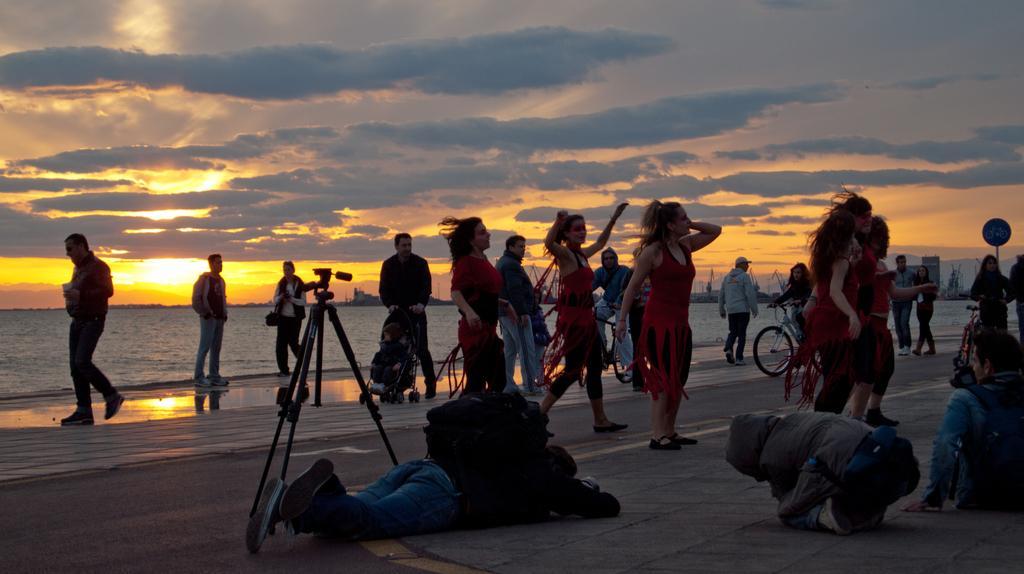Please provide a concise description of this image. This is the picture of a sea. In this image there are group of people dancing and few people are walking, few people are riding bicycle and few are standing. In the foreground there is a person lying on the road. there are two persons sitting on the road. There is a camera and there is a pole. At the back there are buildings and there is water. At the top there is sky and there are clouds and there is a sun. 